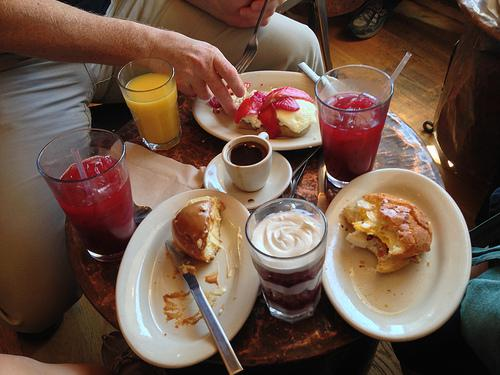Question: what is on the plates?
Choices:
A. The silverware.
B. A napkin.
C. Food.
D. A towel.
Answer with the letter. Answer: C Question: who is eating?
Choices:
A. The children.
B. The man.
C. Grandma.
D. The parents.
Answer with the letter. Answer: B Question: why are the plates on the table?
Choices:
A. For the guests.
B. Decoration.
C. To eat.
D. Don't have room in the cupboard.
Answer with the letter. Answer: C 